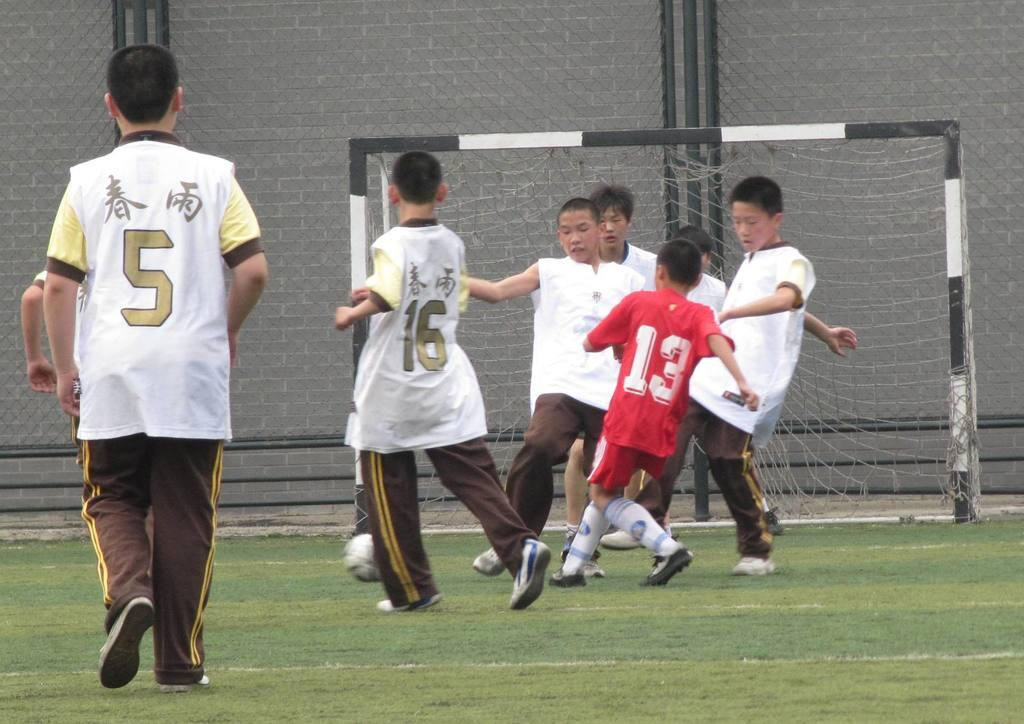Provide a one-sentence caption for the provided image. Player number 13 in a red jersey runs into a group of boys in white jerseys. 